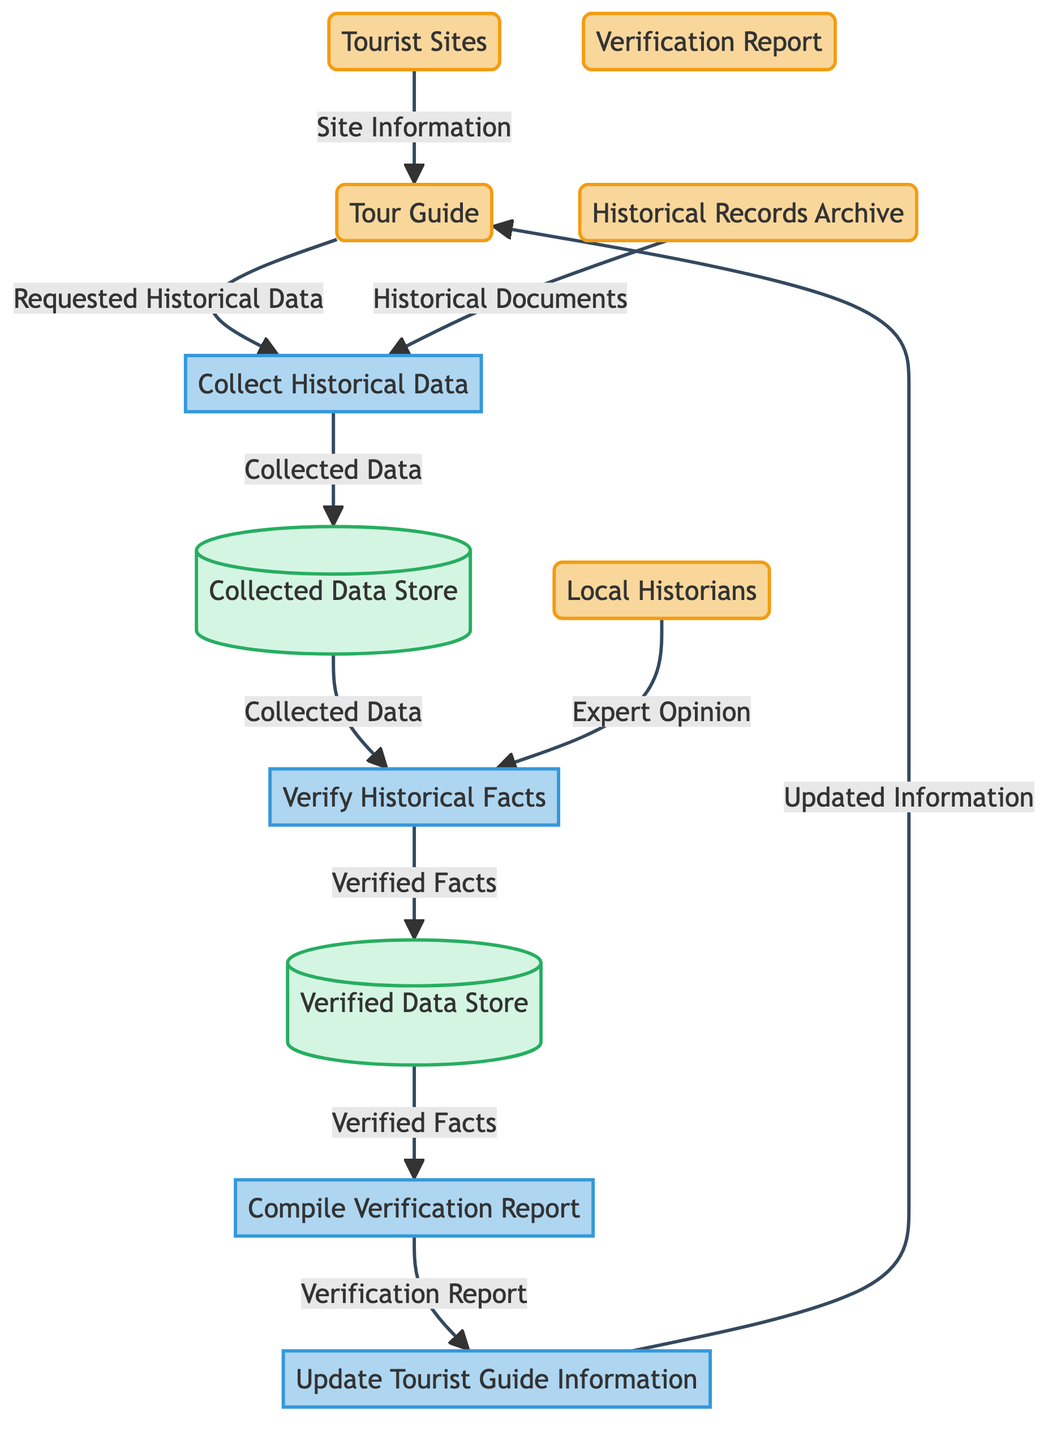What are the entities involved in the process? The diagram lists several entities, including the Tour Guide, Historical Records Archive, Local Historians, Tourist Sites, and Verification Report. These entities are represented in the first section of the diagram and outline the main participants in the data flow process.
Answer: Tour Guide, Historical Records Archive, Local Historians, Tourist Sites, Verification Report How many processes are depicted in the diagram? There are four distinct processes shown in the diagram: Collect Historical Data, Verify Historical Facts, Compile Verification Report, and Update Tourist Guide Information. Each process is represented within the second section of the diagram.
Answer: Four What is the source of "Historical Documents"? The Historical Records Archive is indicated as the source that provides Historical Documents to the Collect Historical Data process. This connection illustrates where the data is coming from for historical research.
Answer: Historical Records Archive What is the flow of data from the "Collect Historical Data" process? The data flow from the Collect Historical Data process includes sending the Collected Data to the Verify Historical Facts process and also storing it in the Collected Data Store. This flow indicates how collected information is handled after gathering.
Answer: Verify Historical Facts, Collected Data Store Which entities provide input to the "Verify Historical Facts" process? The Verify Historical Facts process receives input from two entities: the Local Historians, who provide Expert Opinion, and the Collect Historical Data process, which sends Collected Data. Together, they assist in the verification of historical facts.
Answer: Local Historians, Collect Historical Data What document is created at the end of the process? At the end of the process, the Compile Verification Report process produces a Verification Report, summarizing the verified historical facts. This document is crucial for updating the Tourist Guide Information later in the flow.
Answer: Verification Report Which store holds the collected data before verification? The Collected Data Store holds all collected historical data while awaiting verification. This store acts as a temporary repository before the data is passed on for further validation.
Answer: Collected Data Store What is the final process that updates the Tour Guide? The last process in the diagram that updates the Tour Guide is the Update Tourist Guide Information process. It uses the information from the Verification Report to ensure that the guide's material is current and accurate, reflecting verified historical facts.
Answer: Update Tourist Guide Information 